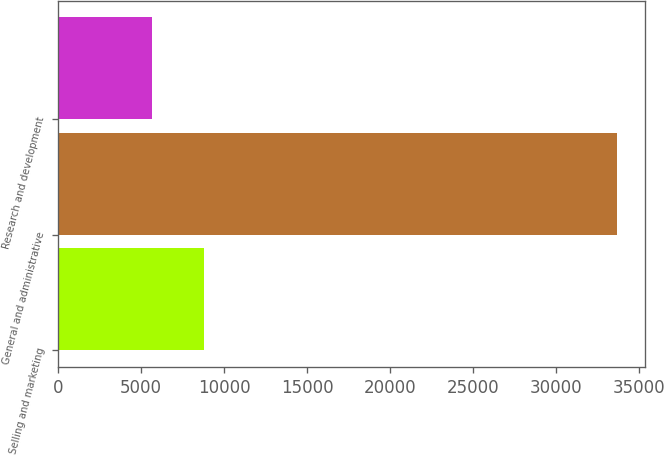Convert chart to OTSL. <chart><loc_0><loc_0><loc_500><loc_500><bar_chart><fcel>Selling and marketing<fcel>General and administrative<fcel>Research and development<nl><fcel>8798<fcel>33636<fcel>5691<nl></chart> 